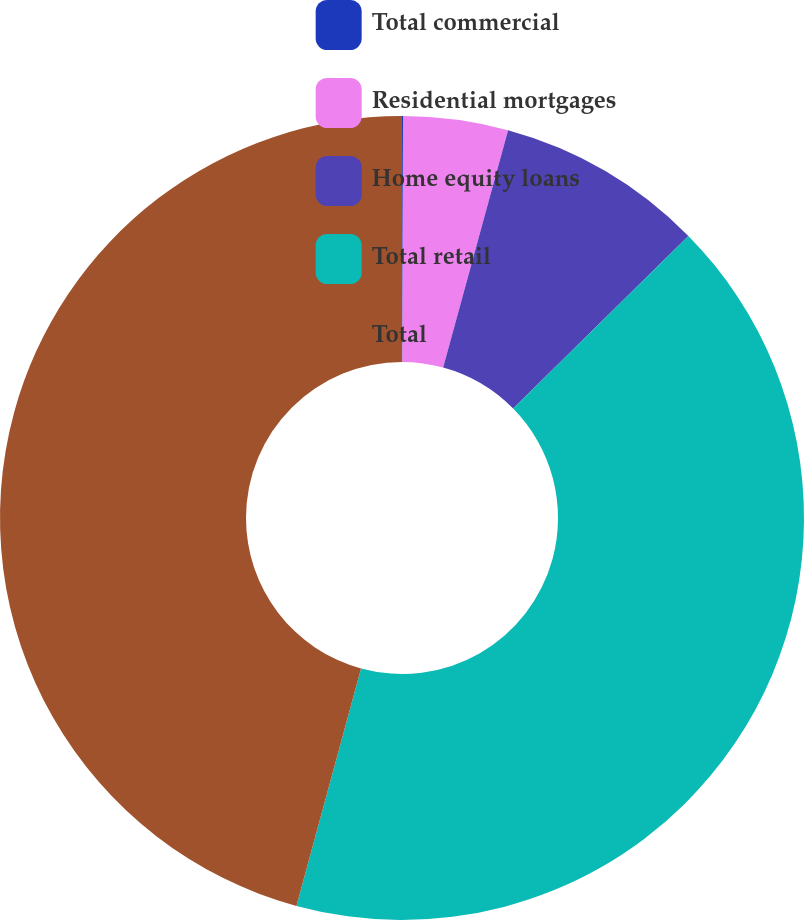Convert chart. <chart><loc_0><loc_0><loc_500><loc_500><pie_chart><fcel>Total commercial<fcel>Residential mortgages<fcel>Home equity loans<fcel>Total retail<fcel>Total<nl><fcel>0.04%<fcel>4.21%<fcel>8.37%<fcel>41.61%<fcel>45.77%<nl></chart> 